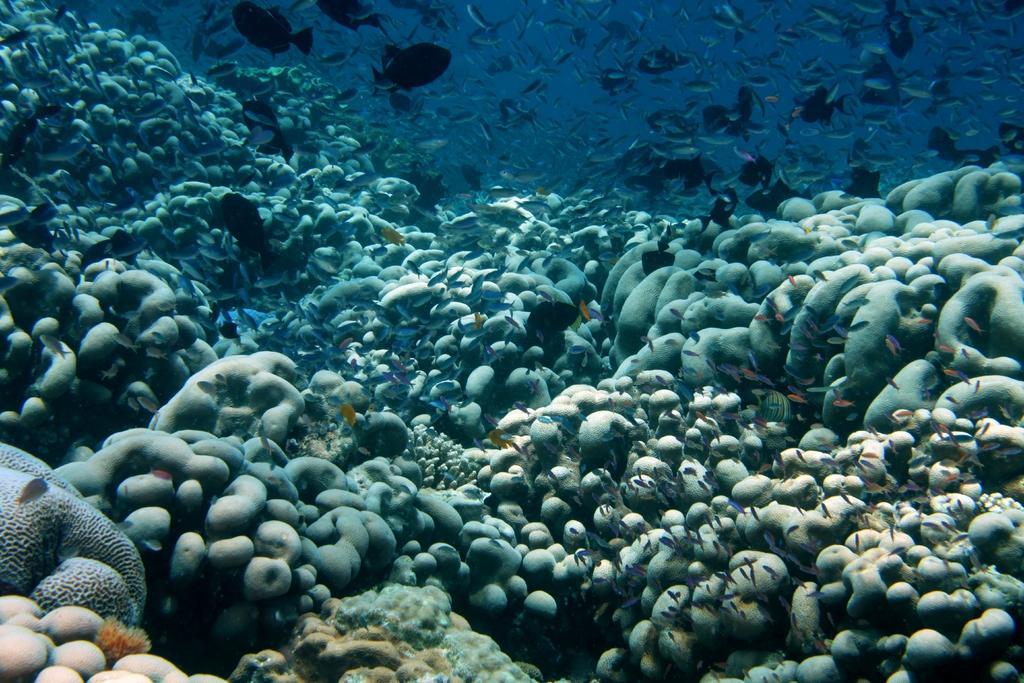Could you give a brief overview of what you see in this image? This is an image clicked inside the water. Here I can see marine species. 